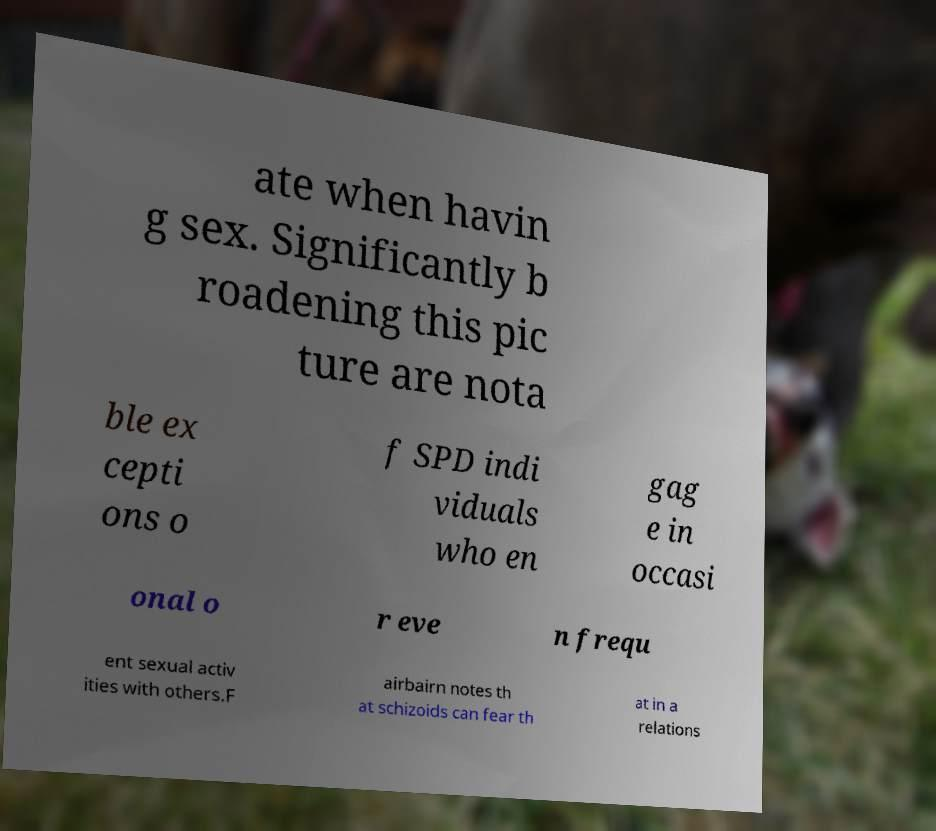Can you accurately transcribe the text from the provided image for me? ate when havin g sex. Significantly b roadening this pic ture are nota ble ex cepti ons o f SPD indi viduals who en gag e in occasi onal o r eve n frequ ent sexual activ ities with others.F airbairn notes th at schizoids can fear th at in a relations 